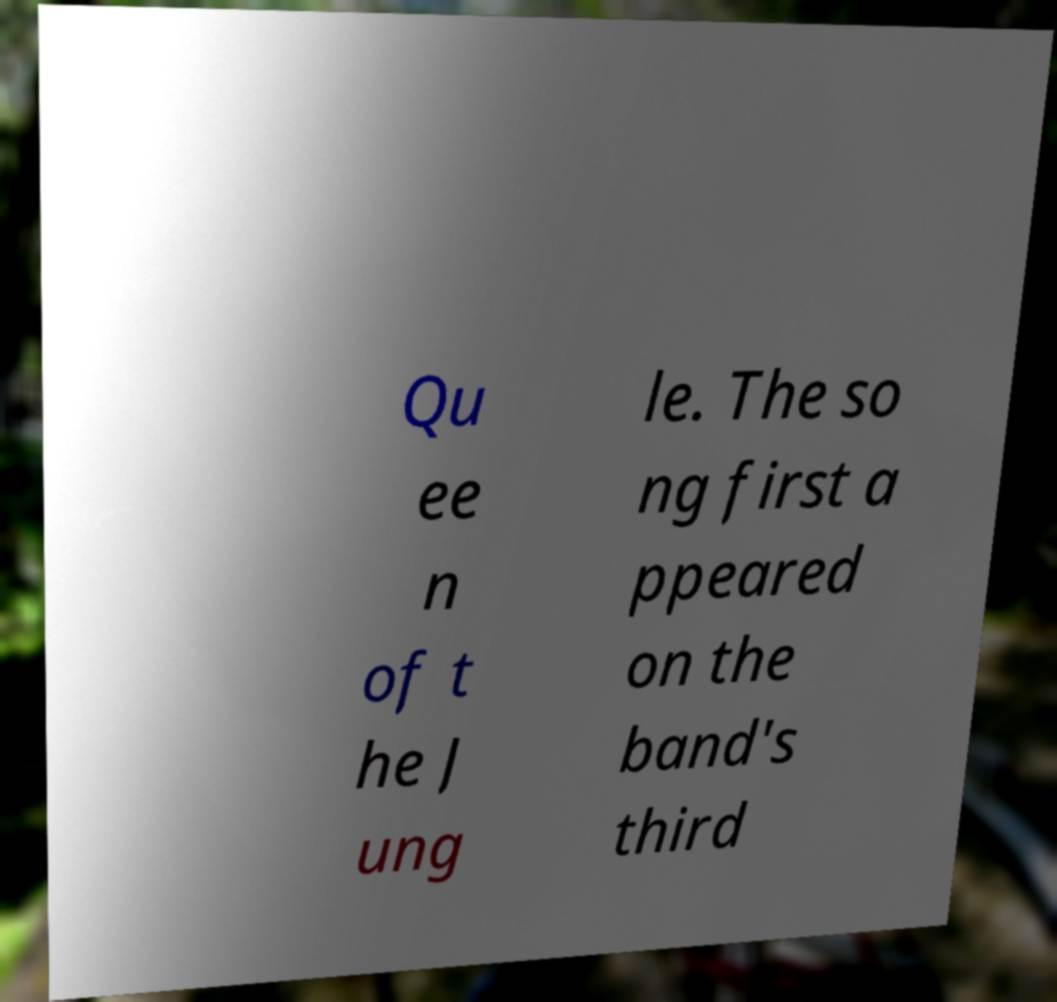Please read and relay the text visible in this image. What does it say? Qu ee n of t he J ung le. The so ng first a ppeared on the band's third 